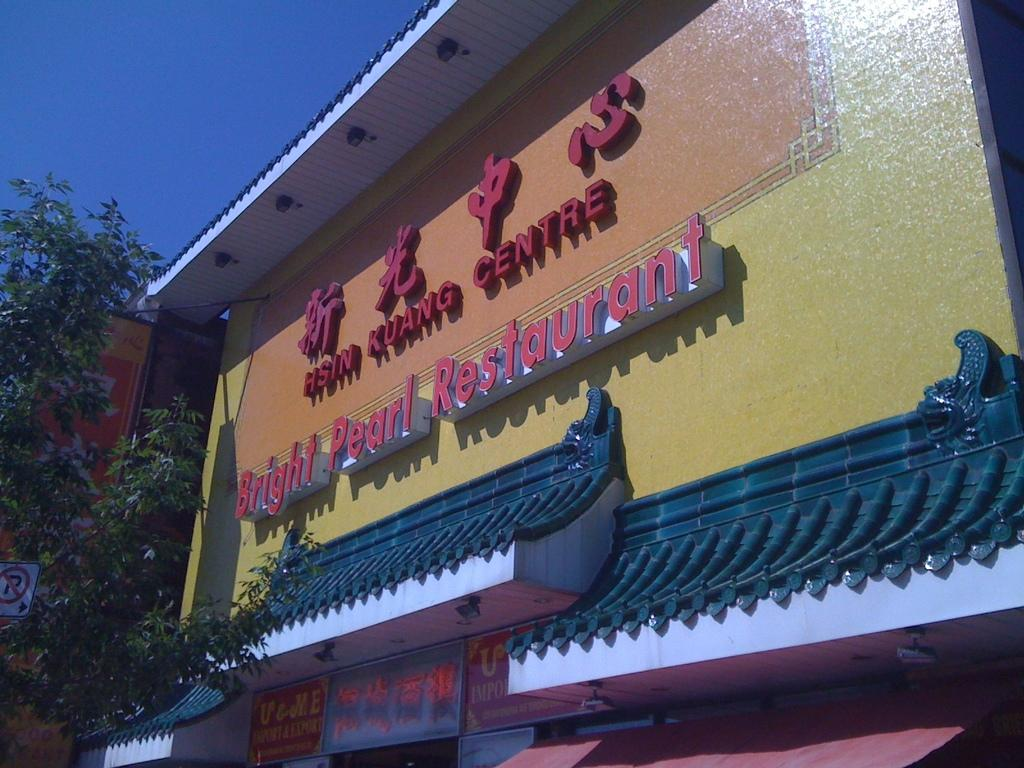<image>
Describe the image concisely. A tall yellow building says Bright Pearl Restaurant. 